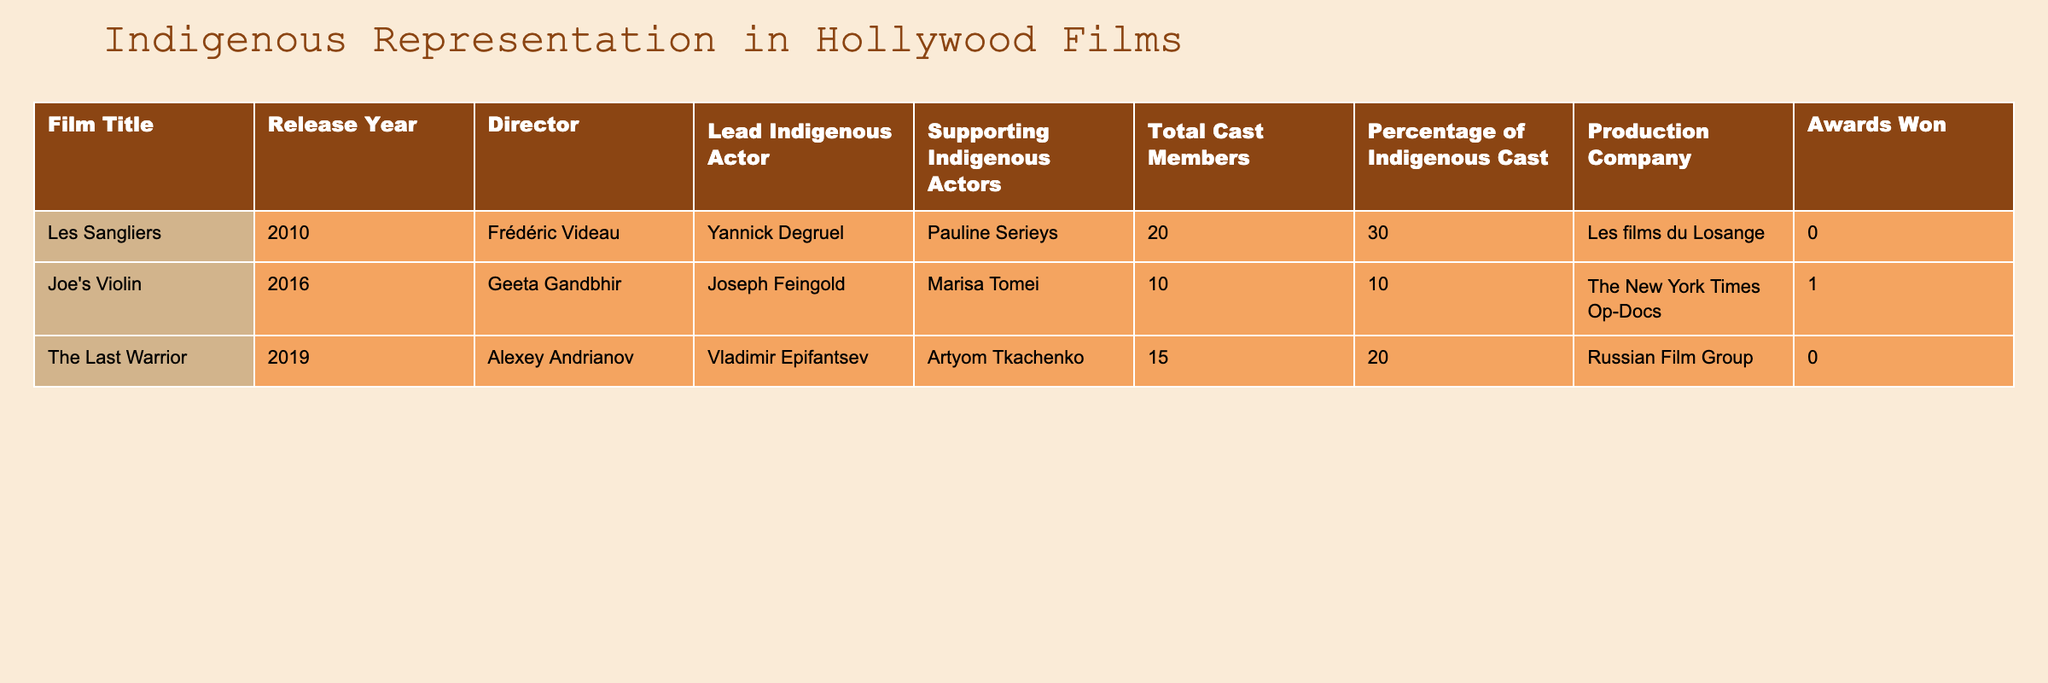What is the title of the film released in 2016? The table lists the film titles along with their release years. The 2016 film is "Joe's Violin".
Answer: "Joe's Violin" Which film has the highest percentage of Indigenous cast? The table shows the "Percentage of Indigenous Cast" for each film. "Les Sangliers" has the highest percentage at 30%.
Answer: 30% How many awards were won by the film "The Last Warrior"? The table specifies the number of awards won by each film. "The Last Warrior" has won 0 awards.
Answer: 0 Is there any film in the table that features only one Indigenous actor? The table shows the number of Lead and Supporting Indigenous Actors. "Joe's Violin" features only one Indigenous actor, Joseph Feingold.
Answer: Yes What is the average number of total cast members in the films listed? To calculate the average, sum the total cast members (20 + 10 + 15 = 45) and divide by the number of films (3). The average is 45/3 = 15.
Answer: 15 How many total Indigenous actors appear in "Les Sangliers"? "Les Sangliers" has one lead Indigenous actor and one supporting Indigenous actor. Therefore, the total is 1 + 1 = 2 Indigenous actors.
Answer: 2 Are there any films produced by "The New York Times Op-Docs"? The table lists "Joe's Violin" under the Production Company "The New York Times Op-Docs". Hence, there is.
Answer: Yes Which film had more total cast members, "Joe's Violin" or "The Last Warrior"? Check the total cast members: "Joe's Violin" has 10, while "The Last Warrior" has 15. Since 15 > 10, "The Last Warrior" has more.
Answer: "The Last Warrior" What is the total number of Indigenous actors (lead and supporting) in the films listed? Add the Lead and Supporting Indigenous Actors for all films: (1 + 1) in "Les Sangliers", (1 + 1) in "Joe's Violin", and (1 + 1) in "The Last Warrior," which equals 6 Indigenous actors in total.
Answer: 6 How many films were directed by female directors? The table shows that "Joe's Violin" is the only film directed by a female, Geeta Gandbhir. Thus, there is only one.
Answer: 1 